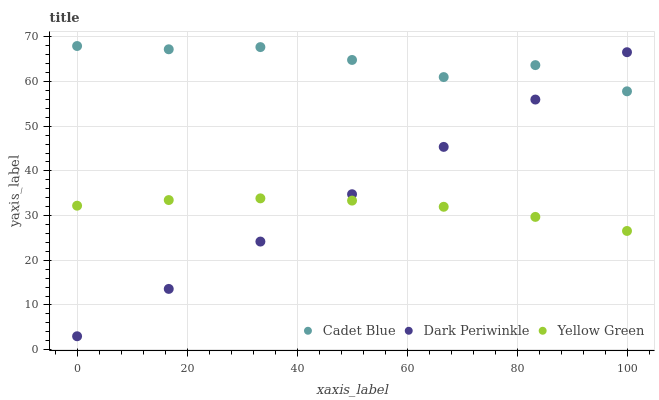Does Yellow Green have the minimum area under the curve?
Answer yes or no. Yes. Does Cadet Blue have the maximum area under the curve?
Answer yes or no. Yes. Does Dark Periwinkle have the minimum area under the curve?
Answer yes or no. No. Does Dark Periwinkle have the maximum area under the curve?
Answer yes or no. No. Is Dark Periwinkle the smoothest?
Answer yes or no. Yes. Is Cadet Blue the roughest?
Answer yes or no. Yes. Is Yellow Green the smoothest?
Answer yes or no. No. Is Yellow Green the roughest?
Answer yes or no. No. Does Dark Periwinkle have the lowest value?
Answer yes or no. Yes. Does Yellow Green have the lowest value?
Answer yes or no. No. Does Cadet Blue have the highest value?
Answer yes or no. Yes. Does Dark Periwinkle have the highest value?
Answer yes or no. No. Is Yellow Green less than Cadet Blue?
Answer yes or no. Yes. Is Cadet Blue greater than Yellow Green?
Answer yes or no. Yes. Does Yellow Green intersect Dark Periwinkle?
Answer yes or no. Yes. Is Yellow Green less than Dark Periwinkle?
Answer yes or no. No. Is Yellow Green greater than Dark Periwinkle?
Answer yes or no. No. Does Yellow Green intersect Cadet Blue?
Answer yes or no. No. 